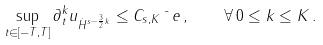<formula> <loc_0><loc_0><loc_500><loc_500>\sup _ { t \in [ - T , T ] } \| \partial _ { t } ^ { k } u \| _ { \dot { H } ^ { s - \frac { 3 } { 2 } k } } \leq C _ { s , K } \bar { \ } e \, , \quad \forall \, 0 \leq k \leq K \, .</formula> 